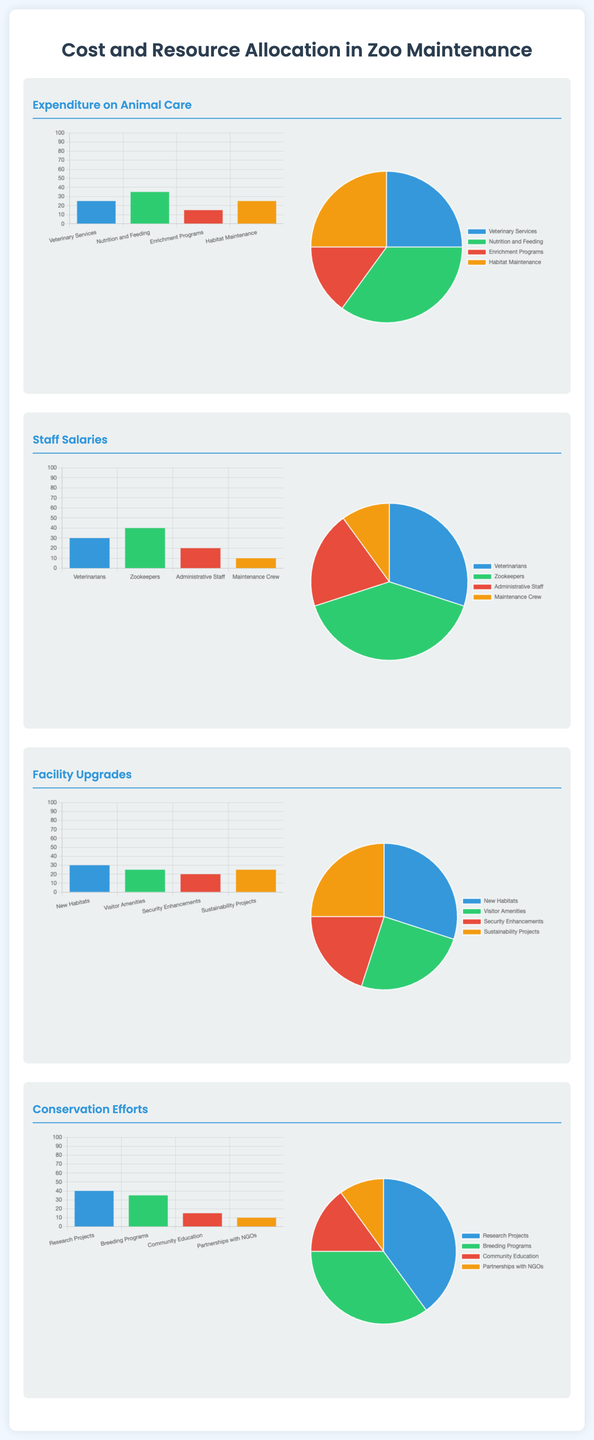What is the percentage allocated to Veterinary Services? The percentage allocated to Veterinary Services is shown in the pie chart under Expenditure on Animal Care.
Answer: 25 Which category receives the highest allocation in Staff Salaries? The category with the highest allocation in Staff Salaries is indicated in the corresponding pie chart.
Answer: Zookeepers What is the main focus of the conservation efforts? The main focus is detailed in the break down of percentages represented in the conservation section.
Answer: Research Projects How much percentage is allocated for New Habitats in Facility Upgrades? The percentage allocated for New Habitats can be found on the pie chart under Facility Upgrades.
Answer: 30 What is the total percentage assigned to Nutrition and Feeding? The total percentage assigned to Nutrition and Feeding is specifically listed in the Expenditure on Animal Care section.
Answer: 35 What percentage of the budget is spent on Community Education? The percentage spent on Community Education is noted in the Conservation Efforts section.
Answer: 15 Which two categories have the same percentage in Facility Upgrades? The categories with the same percentage can be analyzed from the pie chart provided for Facility Upgrades.
Answer: Visitor Amenities and Sustainability Projects What is the total percentage assigned to Maintenance Crew? The total percentage assigned to Maintenance Crew is explicitly stated in the Staff Salaries section.
Answer: 10 Which type of chart is used to depict the data for Conservation Efforts? The type of chart used in the Conservation Efforts section can be identified through the document's visual representation.
Answer: Pie chart 